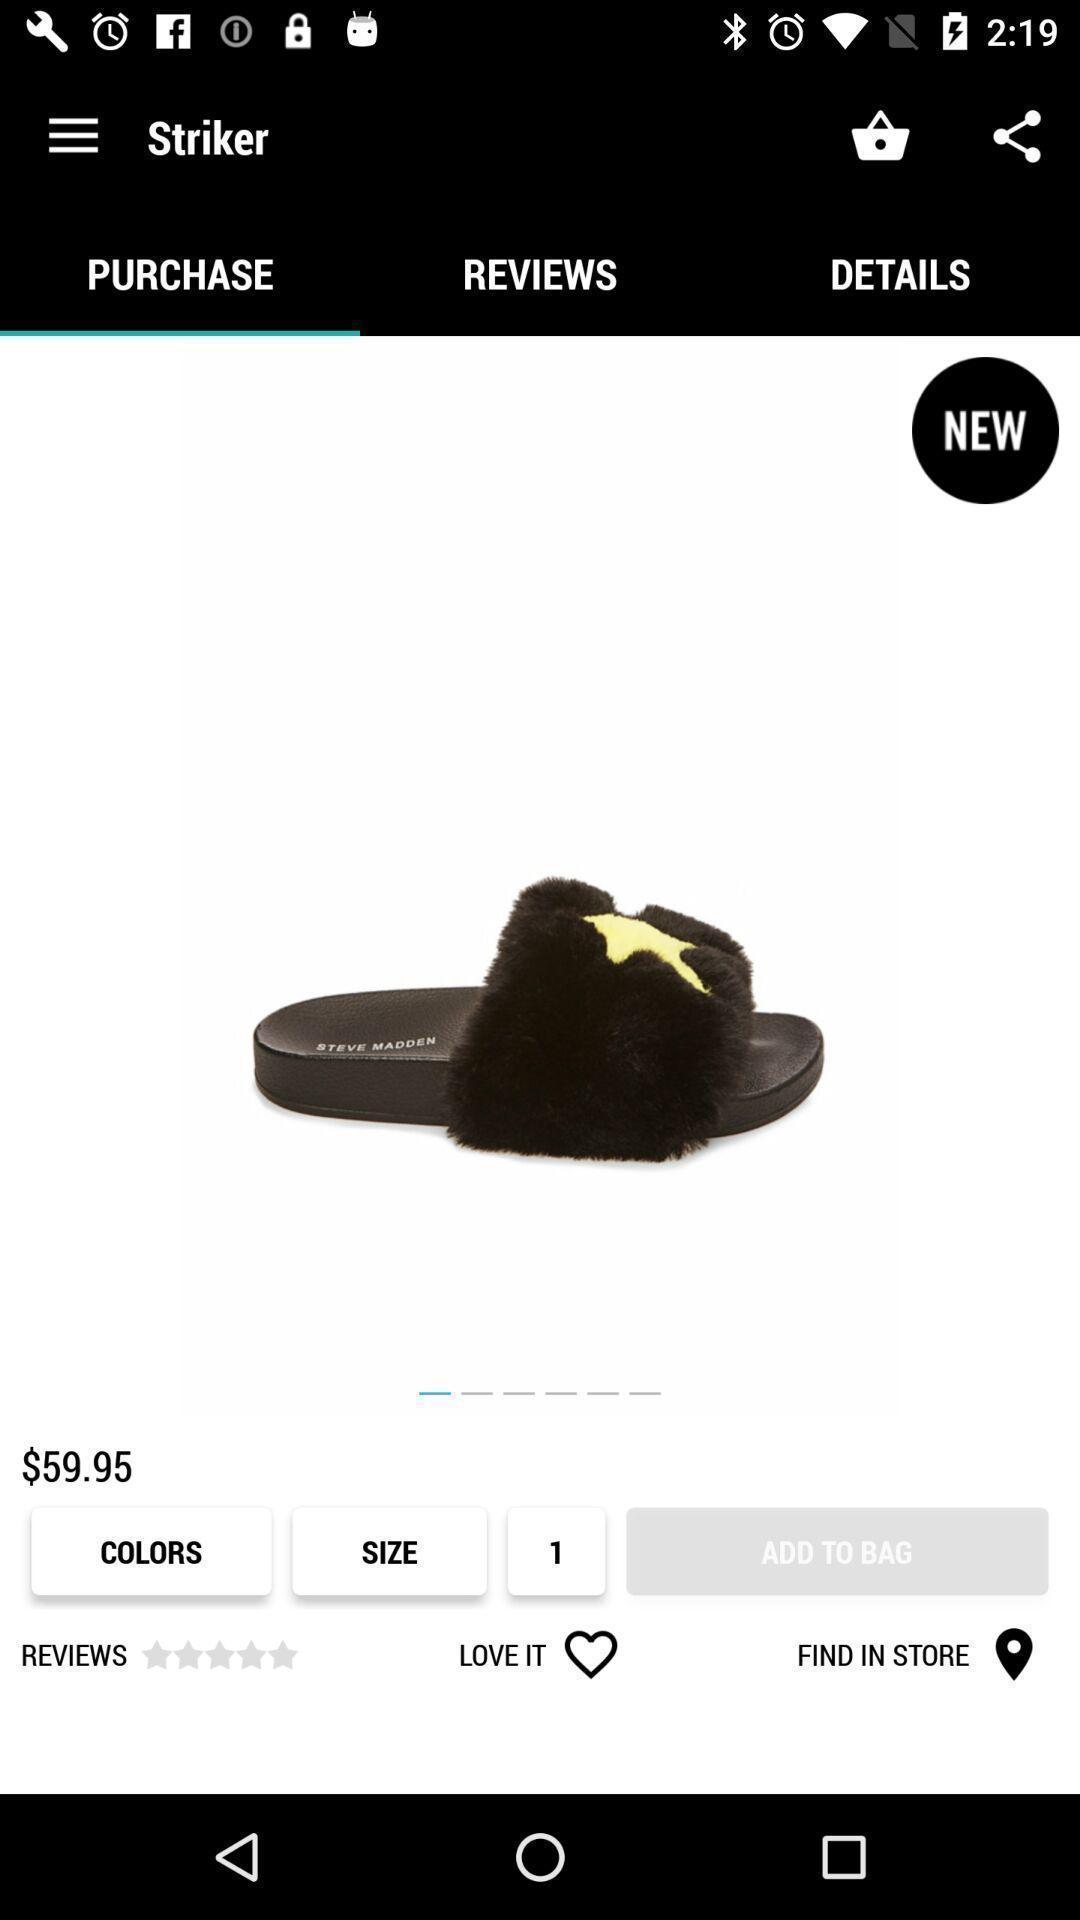Provide a detailed account of this screenshot. Product image displayed includes various details of online shopping app. 